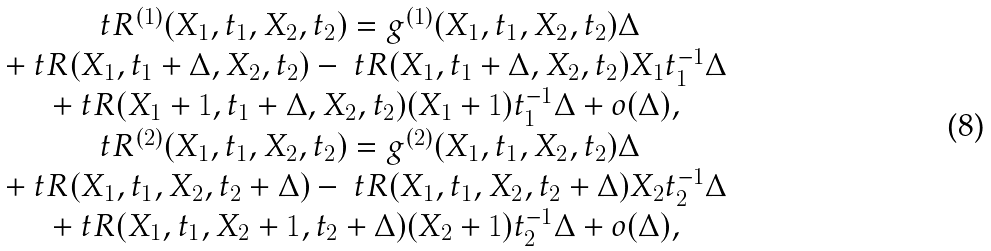Convert formula to latex. <formula><loc_0><loc_0><loc_500><loc_500>\begin{array} { c } \ t R ^ { ( 1 ) } ( X _ { 1 } , t _ { 1 } , X _ { 2 } , t _ { 2 } ) = g ^ { ( 1 ) } ( X _ { 1 } , t _ { 1 } , X _ { 2 } , t _ { 2 } ) \Delta \\ + \ t R ( X _ { 1 } , t _ { 1 } + \Delta , X _ { 2 } , t _ { 2 } ) - \ t R ( X _ { 1 } , t _ { 1 } + \Delta , X _ { 2 } , t _ { 2 } ) X _ { 1 } t _ { 1 } ^ { - 1 } \Delta \\ + \ t R ( X _ { 1 } + 1 , t _ { 1 } + \Delta , X _ { 2 } , t _ { 2 } ) ( X _ { 1 } + 1 ) t _ { 1 } ^ { - 1 } \Delta + o ( \Delta ) , \\ \ t R ^ { ( 2 ) } ( X _ { 1 } , t _ { 1 } , X _ { 2 } , t _ { 2 } ) = g ^ { ( 2 ) } ( X _ { 1 } , t _ { 1 } , X _ { 2 } , t _ { 2 } ) \Delta \\ + \ t R ( X _ { 1 } , t _ { 1 } , X _ { 2 } , t _ { 2 } + \Delta ) - \ t R ( X _ { 1 } , t _ { 1 } , X _ { 2 } , t _ { 2 } + \Delta ) X _ { 2 } t _ { 2 } ^ { - 1 } \Delta \\ + \ t R ( X _ { 1 } , t _ { 1 } , X _ { 2 } + 1 , t _ { 2 } + \Delta ) ( X _ { 2 } + 1 ) t _ { 2 } ^ { - 1 } \Delta + o ( \Delta ) , \end{array}</formula> 